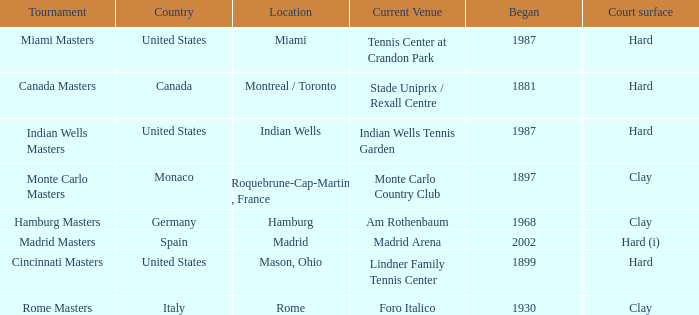Rome is in which country? Italy. 